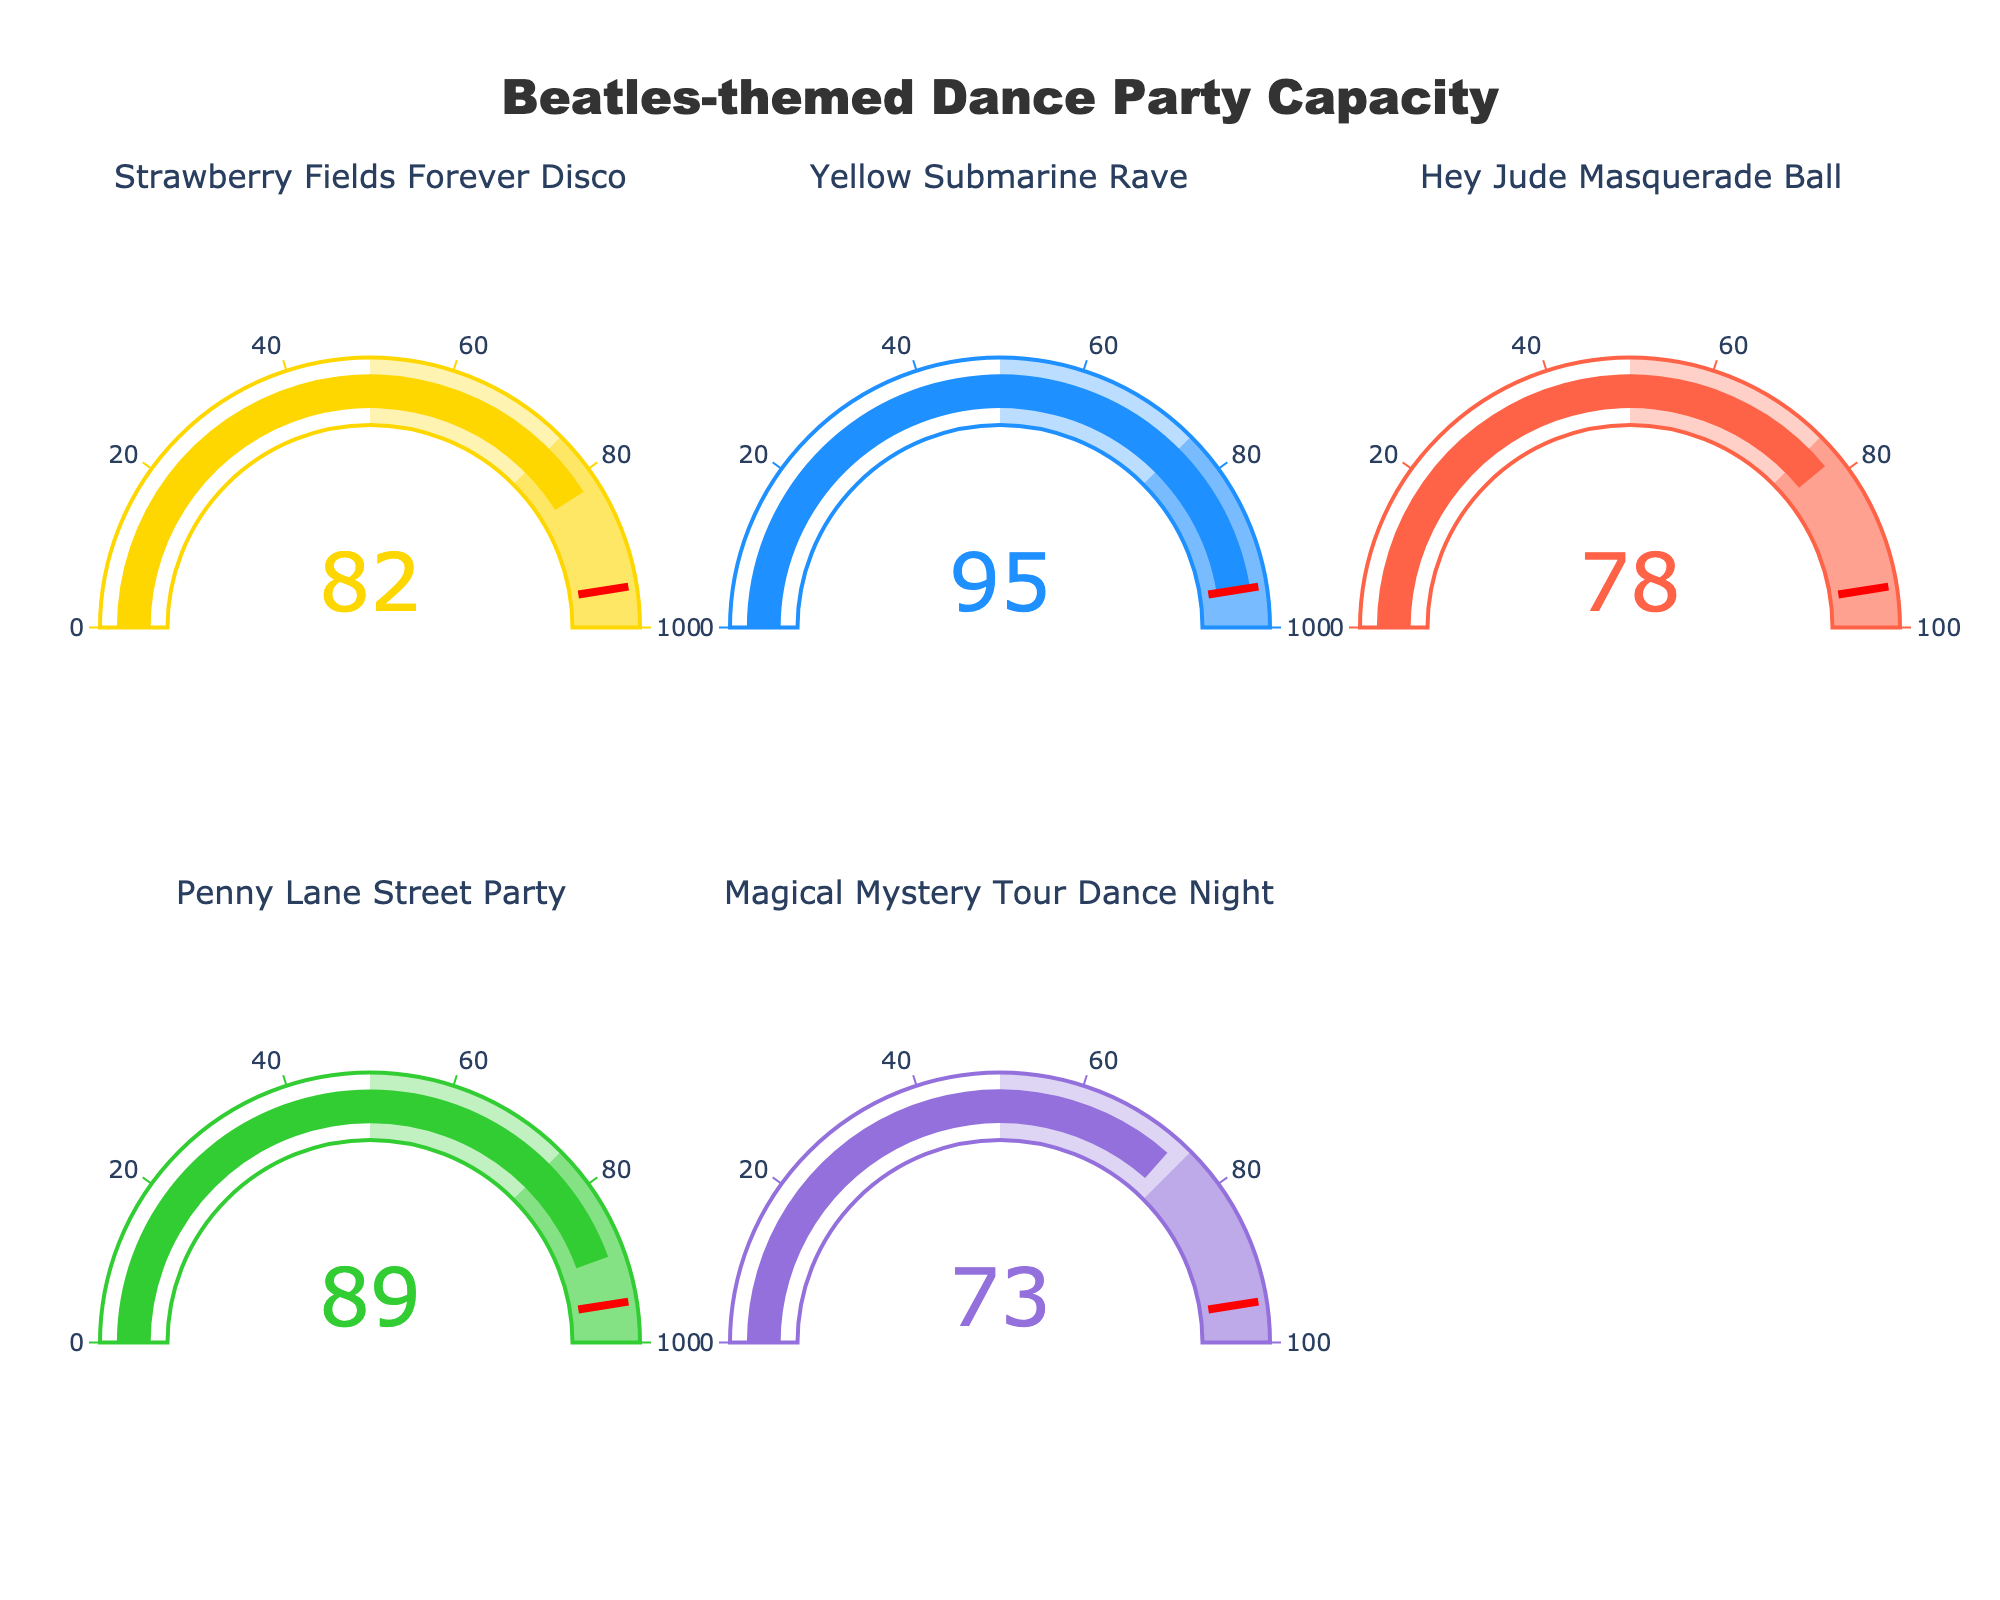What is the title of the figure? The title of the figure is written at the top and is centrally aligned. It clearly states the purpose of the visual.
Answer: Beatles-themed Dance Party Capacity How many events are depicted in the figure? By counting the number of gauges in the figure, we can determine the number of events.
Answer: 5 Which event has the highest capacity filled? By analyzing the values on the gauges, we identify the event with the highest percentage. The gauge for "Yellow Submarine Rave" shows a capacity filled of 95%.
Answer: Yellow Submarine Rave What is the average capacity filled across all events? Sum up the percentages of capacity filled for each event and divide by the number of events. (82 + 95 + 78 + 89 + 73) / 5 = 83.4
Answer: 83.4 Which event has the lowest capacity filled? By comparing the values on the gauges, we find the lowest value. The gauge for "Magical Mystery Tour Dance Night" shows 73%.
Answer: Magical Mystery Tour Dance Night Is there any event with a capacity filled less than 80%? Check each gauge for any value less than 80%. "Hey Jude Masquerade Ball" is at 78%, and "Magical Mystery Tour Dance Night" is at 73%.
Answer: Yes How much more capacity filled does the "Penny Lane Street Party" have compared to the "Hey Jude Masquerade Ball"? Subtract the capacity filled percentage of "Hey Jude Masquerade Ball" from that of "Penny Lane Street Party". 89% - 78% = 11%
Answer: 11% What is the combined capacity filled of "Strawberry Fields Forever Disco" and "Magical Mystery Tour Dance Night"? Add the percentages of capacity filled for these two events. 82% + 73% = 155%
Answer: 155% Which two events have more than 90% capacity filled? Check each gauge for values above 90%. "Yellow Submarine Rave" with 95% and "Penny Lane Street Party" with 89% come close, but only "Yellow Submarine Rave" qualifies.
Answer: Yellow Submarine Rave If the total event capacity is 500, how many attendees are there in the "Strawberry Fields Forever Disco"? Calculate the number of attendees based on the percentage filled. (82 / 100) * 500 = 410
Answer: 410 